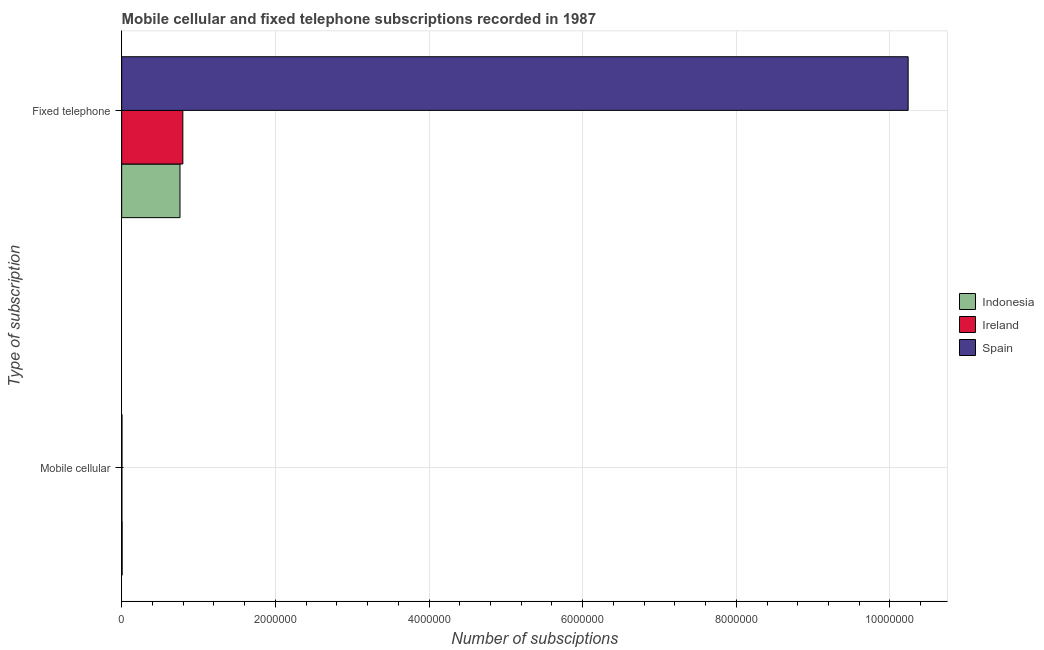Are the number of bars per tick equal to the number of legend labels?
Provide a short and direct response. Yes. Are the number of bars on each tick of the Y-axis equal?
Provide a short and direct response. Yes. How many bars are there on the 2nd tick from the top?
Your response must be concise. 3. How many bars are there on the 2nd tick from the bottom?
Keep it short and to the point. 3. What is the label of the 1st group of bars from the top?
Offer a very short reply. Fixed telephone. What is the number of fixed telephone subscriptions in Ireland?
Your response must be concise. 7.96e+05. Across all countries, what is the maximum number of mobile cellular subscriptions?
Offer a very short reply. 6321. Across all countries, what is the minimum number of mobile cellular subscriptions?
Your answer should be very brief. 3475. In which country was the number of mobile cellular subscriptions maximum?
Provide a succinct answer. Indonesia. In which country was the number of fixed telephone subscriptions minimum?
Keep it short and to the point. Indonesia. What is the total number of fixed telephone subscriptions in the graph?
Make the answer very short. 1.18e+07. What is the difference between the number of fixed telephone subscriptions in Indonesia and that in Spain?
Keep it short and to the point. -9.48e+06. What is the difference between the number of fixed telephone subscriptions in Indonesia and the number of mobile cellular subscriptions in Ireland?
Keep it short and to the point. 7.56e+05. What is the average number of fixed telephone subscriptions per country?
Offer a very short reply. 3.93e+06. What is the difference between the number of mobile cellular subscriptions and number of fixed telephone subscriptions in Ireland?
Give a very brief answer. -7.93e+05. In how many countries, is the number of mobile cellular subscriptions greater than 3200000 ?
Make the answer very short. 0. What is the ratio of the number of fixed telephone subscriptions in Ireland to that in Indonesia?
Make the answer very short. 1.05. Is the number of mobile cellular subscriptions in Indonesia less than that in Spain?
Provide a short and direct response. No. In how many countries, is the number of mobile cellular subscriptions greater than the average number of mobile cellular subscriptions taken over all countries?
Your response must be concise. 1. What does the 2nd bar from the bottom in Fixed telephone represents?
Give a very brief answer. Ireland. How many bars are there?
Make the answer very short. 6. What is the difference between two consecutive major ticks on the X-axis?
Make the answer very short. 2.00e+06. Are the values on the major ticks of X-axis written in scientific E-notation?
Your answer should be very brief. No. Where does the legend appear in the graph?
Offer a very short reply. Center right. How many legend labels are there?
Make the answer very short. 3. How are the legend labels stacked?
Provide a succinct answer. Vertical. What is the title of the graph?
Your answer should be very brief. Mobile cellular and fixed telephone subscriptions recorded in 1987. What is the label or title of the X-axis?
Keep it short and to the point. Number of subsciptions. What is the label or title of the Y-axis?
Give a very brief answer. Type of subscription. What is the Number of subsciptions of Indonesia in Mobile cellular?
Keep it short and to the point. 6321. What is the Number of subsciptions in Ireland in Mobile cellular?
Your answer should be very brief. 3475. What is the Number of subsciptions in Spain in Mobile cellular?
Ensure brevity in your answer.  4200. What is the Number of subsciptions of Indonesia in Fixed telephone?
Ensure brevity in your answer.  7.59e+05. What is the Number of subsciptions in Ireland in Fixed telephone?
Make the answer very short. 7.96e+05. What is the Number of subsciptions of Spain in Fixed telephone?
Provide a succinct answer. 1.02e+07. Across all Type of subscription, what is the maximum Number of subsciptions in Indonesia?
Ensure brevity in your answer.  7.59e+05. Across all Type of subscription, what is the maximum Number of subsciptions of Ireland?
Provide a short and direct response. 7.96e+05. Across all Type of subscription, what is the maximum Number of subsciptions in Spain?
Offer a terse response. 1.02e+07. Across all Type of subscription, what is the minimum Number of subsciptions in Indonesia?
Your answer should be very brief. 6321. Across all Type of subscription, what is the minimum Number of subsciptions of Ireland?
Ensure brevity in your answer.  3475. Across all Type of subscription, what is the minimum Number of subsciptions of Spain?
Make the answer very short. 4200. What is the total Number of subsciptions in Indonesia in the graph?
Offer a terse response. 7.65e+05. What is the total Number of subsciptions in Ireland in the graph?
Keep it short and to the point. 8.00e+05. What is the total Number of subsciptions of Spain in the graph?
Ensure brevity in your answer.  1.02e+07. What is the difference between the Number of subsciptions in Indonesia in Mobile cellular and that in Fixed telephone?
Keep it short and to the point. -7.53e+05. What is the difference between the Number of subsciptions of Ireland in Mobile cellular and that in Fixed telephone?
Provide a short and direct response. -7.93e+05. What is the difference between the Number of subsciptions of Spain in Mobile cellular and that in Fixed telephone?
Offer a terse response. -1.02e+07. What is the difference between the Number of subsciptions in Indonesia in Mobile cellular and the Number of subsciptions in Ireland in Fixed telephone?
Give a very brief answer. -7.90e+05. What is the difference between the Number of subsciptions in Indonesia in Mobile cellular and the Number of subsciptions in Spain in Fixed telephone?
Make the answer very short. -1.02e+07. What is the difference between the Number of subsciptions of Ireland in Mobile cellular and the Number of subsciptions of Spain in Fixed telephone?
Offer a terse response. -1.02e+07. What is the average Number of subsciptions of Indonesia per Type of subscription?
Provide a short and direct response. 3.83e+05. What is the average Number of subsciptions of Ireland per Type of subscription?
Offer a very short reply. 4.00e+05. What is the average Number of subsciptions of Spain per Type of subscription?
Provide a succinct answer. 5.12e+06. What is the difference between the Number of subsciptions of Indonesia and Number of subsciptions of Ireland in Mobile cellular?
Your answer should be very brief. 2846. What is the difference between the Number of subsciptions in Indonesia and Number of subsciptions in Spain in Mobile cellular?
Give a very brief answer. 2121. What is the difference between the Number of subsciptions of Ireland and Number of subsciptions of Spain in Mobile cellular?
Ensure brevity in your answer.  -725. What is the difference between the Number of subsciptions in Indonesia and Number of subsciptions in Ireland in Fixed telephone?
Give a very brief answer. -3.71e+04. What is the difference between the Number of subsciptions in Indonesia and Number of subsciptions in Spain in Fixed telephone?
Offer a very short reply. -9.48e+06. What is the difference between the Number of subsciptions in Ireland and Number of subsciptions in Spain in Fixed telephone?
Provide a succinct answer. -9.44e+06. What is the ratio of the Number of subsciptions of Indonesia in Mobile cellular to that in Fixed telephone?
Your response must be concise. 0.01. What is the ratio of the Number of subsciptions in Ireland in Mobile cellular to that in Fixed telephone?
Your answer should be compact. 0. What is the difference between the highest and the second highest Number of subsciptions in Indonesia?
Give a very brief answer. 7.53e+05. What is the difference between the highest and the second highest Number of subsciptions in Ireland?
Your answer should be very brief. 7.93e+05. What is the difference between the highest and the second highest Number of subsciptions of Spain?
Your answer should be compact. 1.02e+07. What is the difference between the highest and the lowest Number of subsciptions of Indonesia?
Ensure brevity in your answer.  7.53e+05. What is the difference between the highest and the lowest Number of subsciptions of Ireland?
Your answer should be very brief. 7.93e+05. What is the difference between the highest and the lowest Number of subsciptions of Spain?
Offer a terse response. 1.02e+07. 